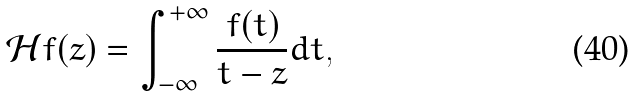<formula> <loc_0><loc_0><loc_500><loc_500>\mathcal { H } f ( z ) = \int _ { - \infty } ^ { + \infty } \frac { f ( t ) } { t - z } d t ,</formula> 